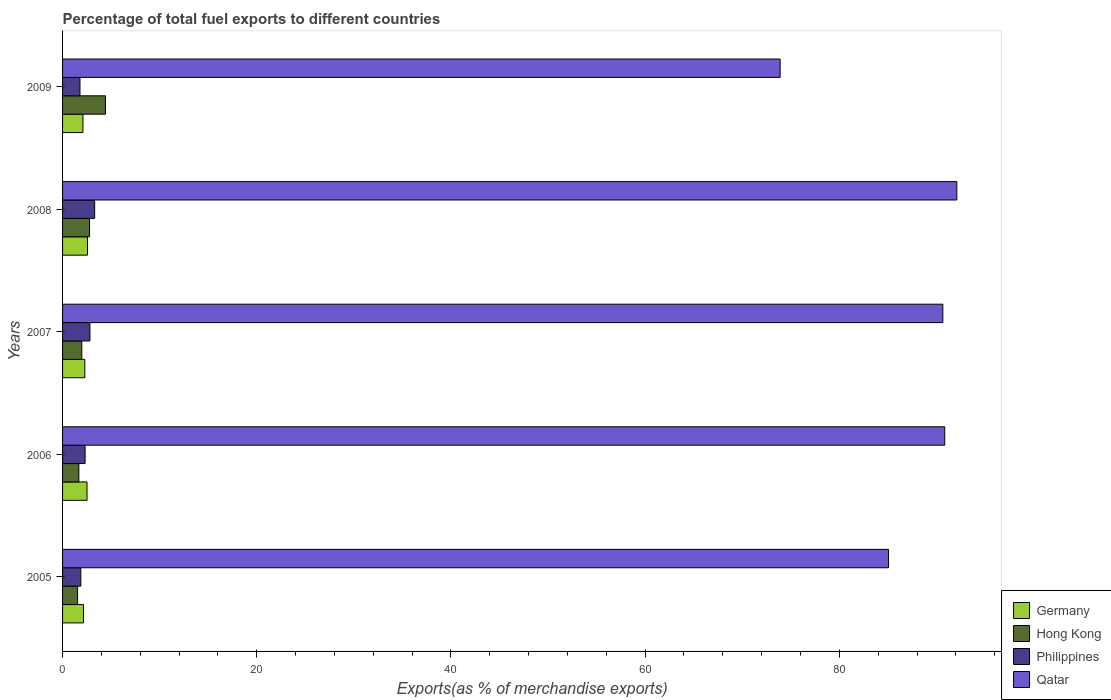How many groups of bars are there?
Give a very brief answer. 5. Are the number of bars per tick equal to the number of legend labels?
Offer a terse response. Yes. Are the number of bars on each tick of the Y-axis equal?
Your response must be concise. Yes. How many bars are there on the 1st tick from the bottom?
Offer a terse response. 4. What is the percentage of exports to different countries in Hong Kong in 2005?
Provide a succinct answer. 1.54. Across all years, what is the maximum percentage of exports to different countries in Germany?
Give a very brief answer. 2.57. Across all years, what is the minimum percentage of exports to different countries in Qatar?
Provide a short and direct response. 73.9. In which year was the percentage of exports to different countries in Qatar maximum?
Keep it short and to the point. 2008. In which year was the percentage of exports to different countries in Philippines minimum?
Ensure brevity in your answer.  2009. What is the total percentage of exports to different countries in Philippines in the graph?
Your answer should be compact. 12.12. What is the difference between the percentage of exports to different countries in Qatar in 2007 and that in 2009?
Provide a succinct answer. 16.76. What is the difference between the percentage of exports to different countries in Germany in 2005 and the percentage of exports to different countries in Qatar in 2007?
Give a very brief answer. -88.5. What is the average percentage of exports to different countries in Germany per year?
Offer a very short reply. 2.33. In the year 2005, what is the difference between the percentage of exports to different countries in Qatar and percentage of exports to different countries in Hong Kong?
Ensure brevity in your answer.  83.52. In how many years, is the percentage of exports to different countries in Qatar greater than 76 %?
Your answer should be compact. 4. What is the ratio of the percentage of exports to different countries in Germany in 2007 to that in 2009?
Ensure brevity in your answer.  1.09. Is the percentage of exports to different countries in Hong Kong in 2005 less than that in 2007?
Provide a short and direct response. Yes. What is the difference between the highest and the second highest percentage of exports to different countries in Germany?
Keep it short and to the point. 0.05. What is the difference between the highest and the lowest percentage of exports to different countries in Qatar?
Your answer should be compact. 18.2. Is it the case that in every year, the sum of the percentage of exports to different countries in Hong Kong and percentage of exports to different countries in Germany is greater than the sum of percentage of exports to different countries in Qatar and percentage of exports to different countries in Philippines?
Make the answer very short. No. What does the 4th bar from the bottom in 2005 represents?
Offer a very short reply. Qatar. Is it the case that in every year, the sum of the percentage of exports to different countries in Qatar and percentage of exports to different countries in Germany is greater than the percentage of exports to different countries in Hong Kong?
Offer a very short reply. Yes. Does the graph contain grids?
Provide a short and direct response. No. How are the legend labels stacked?
Make the answer very short. Vertical. What is the title of the graph?
Your response must be concise. Percentage of total fuel exports to different countries. What is the label or title of the X-axis?
Give a very brief answer. Exports(as % of merchandise exports). What is the label or title of the Y-axis?
Offer a very short reply. Years. What is the Exports(as % of merchandise exports) in Germany in 2005?
Offer a very short reply. 2.16. What is the Exports(as % of merchandise exports) of Hong Kong in 2005?
Offer a very short reply. 1.54. What is the Exports(as % of merchandise exports) in Philippines in 2005?
Ensure brevity in your answer.  1.88. What is the Exports(as % of merchandise exports) of Qatar in 2005?
Provide a succinct answer. 85.06. What is the Exports(as % of merchandise exports) of Germany in 2006?
Give a very brief answer. 2.52. What is the Exports(as % of merchandise exports) of Hong Kong in 2006?
Your answer should be very brief. 1.68. What is the Exports(as % of merchandise exports) in Philippines in 2006?
Ensure brevity in your answer.  2.32. What is the Exports(as % of merchandise exports) of Qatar in 2006?
Provide a short and direct response. 90.85. What is the Exports(as % of merchandise exports) in Germany in 2007?
Provide a short and direct response. 2.29. What is the Exports(as % of merchandise exports) of Hong Kong in 2007?
Keep it short and to the point. 1.98. What is the Exports(as % of merchandise exports) of Philippines in 2007?
Offer a terse response. 2.82. What is the Exports(as % of merchandise exports) in Qatar in 2007?
Give a very brief answer. 90.66. What is the Exports(as % of merchandise exports) of Germany in 2008?
Your answer should be very brief. 2.57. What is the Exports(as % of merchandise exports) in Hong Kong in 2008?
Provide a succinct answer. 2.78. What is the Exports(as % of merchandise exports) of Philippines in 2008?
Give a very brief answer. 3.3. What is the Exports(as % of merchandise exports) in Qatar in 2008?
Your answer should be compact. 92.1. What is the Exports(as % of merchandise exports) in Germany in 2009?
Make the answer very short. 2.1. What is the Exports(as % of merchandise exports) of Hong Kong in 2009?
Your response must be concise. 4.42. What is the Exports(as % of merchandise exports) in Philippines in 2009?
Offer a terse response. 1.79. What is the Exports(as % of merchandise exports) in Qatar in 2009?
Make the answer very short. 73.9. Across all years, what is the maximum Exports(as % of merchandise exports) in Germany?
Your response must be concise. 2.57. Across all years, what is the maximum Exports(as % of merchandise exports) in Hong Kong?
Your answer should be very brief. 4.42. Across all years, what is the maximum Exports(as % of merchandise exports) in Philippines?
Offer a terse response. 3.3. Across all years, what is the maximum Exports(as % of merchandise exports) in Qatar?
Keep it short and to the point. 92.1. Across all years, what is the minimum Exports(as % of merchandise exports) of Germany?
Make the answer very short. 2.1. Across all years, what is the minimum Exports(as % of merchandise exports) of Hong Kong?
Make the answer very short. 1.54. Across all years, what is the minimum Exports(as % of merchandise exports) of Philippines?
Offer a very short reply. 1.79. Across all years, what is the minimum Exports(as % of merchandise exports) of Qatar?
Your answer should be compact. 73.9. What is the total Exports(as % of merchandise exports) of Germany in the graph?
Make the answer very short. 11.64. What is the total Exports(as % of merchandise exports) in Hong Kong in the graph?
Keep it short and to the point. 12.4. What is the total Exports(as % of merchandise exports) of Philippines in the graph?
Offer a terse response. 12.12. What is the total Exports(as % of merchandise exports) in Qatar in the graph?
Provide a short and direct response. 432.57. What is the difference between the Exports(as % of merchandise exports) of Germany in 2005 and that in 2006?
Ensure brevity in your answer.  -0.36. What is the difference between the Exports(as % of merchandise exports) of Hong Kong in 2005 and that in 2006?
Your answer should be compact. -0.13. What is the difference between the Exports(as % of merchandise exports) in Philippines in 2005 and that in 2006?
Your answer should be compact. -0.44. What is the difference between the Exports(as % of merchandise exports) in Qatar in 2005 and that in 2006?
Offer a very short reply. -5.79. What is the difference between the Exports(as % of merchandise exports) of Germany in 2005 and that in 2007?
Provide a short and direct response. -0.13. What is the difference between the Exports(as % of merchandise exports) of Hong Kong in 2005 and that in 2007?
Your answer should be very brief. -0.44. What is the difference between the Exports(as % of merchandise exports) in Philippines in 2005 and that in 2007?
Offer a very short reply. -0.94. What is the difference between the Exports(as % of merchandise exports) of Qatar in 2005 and that in 2007?
Ensure brevity in your answer.  -5.6. What is the difference between the Exports(as % of merchandise exports) in Germany in 2005 and that in 2008?
Your answer should be compact. -0.41. What is the difference between the Exports(as % of merchandise exports) in Hong Kong in 2005 and that in 2008?
Keep it short and to the point. -1.24. What is the difference between the Exports(as % of merchandise exports) of Philippines in 2005 and that in 2008?
Your answer should be very brief. -1.42. What is the difference between the Exports(as % of merchandise exports) of Qatar in 2005 and that in 2008?
Ensure brevity in your answer.  -7.04. What is the difference between the Exports(as % of merchandise exports) of Germany in 2005 and that in 2009?
Provide a succinct answer. 0.06. What is the difference between the Exports(as % of merchandise exports) of Hong Kong in 2005 and that in 2009?
Make the answer very short. -2.88. What is the difference between the Exports(as % of merchandise exports) in Philippines in 2005 and that in 2009?
Offer a very short reply. 0.09. What is the difference between the Exports(as % of merchandise exports) of Qatar in 2005 and that in 2009?
Offer a terse response. 11.16. What is the difference between the Exports(as % of merchandise exports) of Germany in 2006 and that in 2007?
Provide a short and direct response. 0.23. What is the difference between the Exports(as % of merchandise exports) of Hong Kong in 2006 and that in 2007?
Offer a very short reply. -0.3. What is the difference between the Exports(as % of merchandise exports) of Philippines in 2006 and that in 2007?
Offer a very short reply. -0.5. What is the difference between the Exports(as % of merchandise exports) in Qatar in 2006 and that in 2007?
Make the answer very short. 0.2. What is the difference between the Exports(as % of merchandise exports) in Germany in 2006 and that in 2008?
Keep it short and to the point. -0.05. What is the difference between the Exports(as % of merchandise exports) of Hong Kong in 2006 and that in 2008?
Provide a succinct answer. -1.1. What is the difference between the Exports(as % of merchandise exports) of Philippines in 2006 and that in 2008?
Your answer should be very brief. -0.98. What is the difference between the Exports(as % of merchandise exports) in Qatar in 2006 and that in 2008?
Your answer should be compact. -1.25. What is the difference between the Exports(as % of merchandise exports) in Germany in 2006 and that in 2009?
Make the answer very short. 0.42. What is the difference between the Exports(as % of merchandise exports) in Hong Kong in 2006 and that in 2009?
Your answer should be compact. -2.74. What is the difference between the Exports(as % of merchandise exports) in Philippines in 2006 and that in 2009?
Your response must be concise. 0.53. What is the difference between the Exports(as % of merchandise exports) of Qatar in 2006 and that in 2009?
Make the answer very short. 16.95. What is the difference between the Exports(as % of merchandise exports) of Germany in 2007 and that in 2008?
Give a very brief answer. -0.27. What is the difference between the Exports(as % of merchandise exports) of Hong Kong in 2007 and that in 2008?
Make the answer very short. -0.8. What is the difference between the Exports(as % of merchandise exports) in Philippines in 2007 and that in 2008?
Offer a very short reply. -0.49. What is the difference between the Exports(as % of merchandise exports) in Qatar in 2007 and that in 2008?
Your answer should be very brief. -1.44. What is the difference between the Exports(as % of merchandise exports) of Germany in 2007 and that in 2009?
Give a very brief answer. 0.2. What is the difference between the Exports(as % of merchandise exports) in Hong Kong in 2007 and that in 2009?
Offer a very short reply. -2.44. What is the difference between the Exports(as % of merchandise exports) of Philippines in 2007 and that in 2009?
Your response must be concise. 1.02. What is the difference between the Exports(as % of merchandise exports) in Qatar in 2007 and that in 2009?
Your answer should be very brief. 16.76. What is the difference between the Exports(as % of merchandise exports) of Germany in 2008 and that in 2009?
Your response must be concise. 0.47. What is the difference between the Exports(as % of merchandise exports) in Hong Kong in 2008 and that in 2009?
Offer a very short reply. -1.64. What is the difference between the Exports(as % of merchandise exports) of Philippines in 2008 and that in 2009?
Provide a short and direct response. 1.51. What is the difference between the Exports(as % of merchandise exports) of Qatar in 2008 and that in 2009?
Keep it short and to the point. 18.2. What is the difference between the Exports(as % of merchandise exports) in Germany in 2005 and the Exports(as % of merchandise exports) in Hong Kong in 2006?
Provide a short and direct response. 0.48. What is the difference between the Exports(as % of merchandise exports) of Germany in 2005 and the Exports(as % of merchandise exports) of Philippines in 2006?
Provide a succinct answer. -0.16. What is the difference between the Exports(as % of merchandise exports) of Germany in 2005 and the Exports(as % of merchandise exports) of Qatar in 2006?
Your answer should be very brief. -88.69. What is the difference between the Exports(as % of merchandise exports) of Hong Kong in 2005 and the Exports(as % of merchandise exports) of Philippines in 2006?
Keep it short and to the point. -0.78. What is the difference between the Exports(as % of merchandise exports) of Hong Kong in 2005 and the Exports(as % of merchandise exports) of Qatar in 2006?
Give a very brief answer. -89.31. What is the difference between the Exports(as % of merchandise exports) of Philippines in 2005 and the Exports(as % of merchandise exports) of Qatar in 2006?
Provide a succinct answer. -88.97. What is the difference between the Exports(as % of merchandise exports) of Germany in 2005 and the Exports(as % of merchandise exports) of Hong Kong in 2007?
Offer a very short reply. 0.18. What is the difference between the Exports(as % of merchandise exports) of Germany in 2005 and the Exports(as % of merchandise exports) of Philippines in 2007?
Ensure brevity in your answer.  -0.66. What is the difference between the Exports(as % of merchandise exports) in Germany in 2005 and the Exports(as % of merchandise exports) in Qatar in 2007?
Provide a succinct answer. -88.5. What is the difference between the Exports(as % of merchandise exports) of Hong Kong in 2005 and the Exports(as % of merchandise exports) of Philippines in 2007?
Provide a short and direct response. -1.27. What is the difference between the Exports(as % of merchandise exports) in Hong Kong in 2005 and the Exports(as % of merchandise exports) in Qatar in 2007?
Your response must be concise. -89.11. What is the difference between the Exports(as % of merchandise exports) of Philippines in 2005 and the Exports(as % of merchandise exports) of Qatar in 2007?
Your response must be concise. -88.78. What is the difference between the Exports(as % of merchandise exports) in Germany in 2005 and the Exports(as % of merchandise exports) in Hong Kong in 2008?
Offer a very short reply. -0.62. What is the difference between the Exports(as % of merchandise exports) of Germany in 2005 and the Exports(as % of merchandise exports) of Philippines in 2008?
Make the answer very short. -1.15. What is the difference between the Exports(as % of merchandise exports) in Germany in 2005 and the Exports(as % of merchandise exports) in Qatar in 2008?
Your answer should be very brief. -89.94. What is the difference between the Exports(as % of merchandise exports) in Hong Kong in 2005 and the Exports(as % of merchandise exports) in Philippines in 2008?
Offer a very short reply. -1.76. What is the difference between the Exports(as % of merchandise exports) of Hong Kong in 2005 and the Exports(as % of merchandise exports) of Qatar in 2008?
Make the answer very short. -90.55. What is the difference between the Exports(as % of merchandise exports) in Philippines in 2005 and the Exports(as % of merchandise exports) in Qatar in 2008?
Offer a very short reply. -90.22. What is the difference between the Exports(as % of merchandise exports) in Germany in 2005 and the Exports(as % of merchandise exports) in Hong Kong in 2009?
Your response must be concise. -2.26. What is the difference between the Exports(as % of merchandise exports) of Germany in 2005 and the Exports(as % of merchandise exports) of Philippines in 2009?
Provide a short and direct response. 0.37. What is the difference between the Exports(as % of merchandise exports) in Germany in 2005 and the Exports(as % of merchandise exports) in Qatar in 2009?
Keep it short and to the point. -71.74. What is the difference between the Exports(as % of merchandise exports) of Hong Kong in 2005 and the Exports(as % of merchandise exports) of Philippines in 2009?
Provide a short and direct response. -0.25. What is the difference between the Exports(as % of merchandise exports) of Hong Kong in 2005 and the Exports(as % of merchandise exports) of Qatar in 2009?
Your response must be concise. -72.36. What is the difference between the Exports(as % of merchandise exports) in Philippines in 2005 and the Exports(as % of merchandise exports) in Qatar in 2009?
Give a very brief answer. -72.02. What is the difference between the Exports(as % of merchandise exports) in Germany in 2006 and the Exports(as % of merchandise exports) in Hong Kong in 2007?
Offer a very short reply. 0.54. What is the difference between the Exports(as % of merchandise exports) in Germany in 2006 and the Exports(as % of merchandise exports) in Philippines in 2007?
Ensure brevity in your answer.  -0.3. What is the difference between the Exports(as % of merchandise exports) of Germany in 2006 and the Exports(as % of merchandise exports) of Qatar in 2007?
Provide a short and direct response. -88.14. What is the difference between the Exports(as % of merchandise exports) of Hong Kong in 2006 and the Exports(as % of merchandise exports) of Philippines in 2007?
Provide a short and direct response. -1.14. What is the difference between the Exports(as % of merchandise exports) of Hong Kong in 2006 and the Exports(as % of merchandise exports) of Qatar in 2007?
Keep it short and to the point. -88.98. What is the difference between the Exports(as % of merchandise exports) in Philippines in 2006 and the Exports(as % of merchandise exports) in Qatar in 2007?
Give a very brief answer. -88.34. What is the difference between the Exports(as % of merchandise exports) in Germany in 2006 and the Exports(as % of merchandise exports) in Hong Kong in 2008?
Provide a succinct answer. -0.26. What is the difference between the Exports(as % of merchandise exports) in Germany in 2006 and the Exports(as % of merchandise exports) in Philippines in 2008?
Offer a terse response. -0.79. What is the difference between the Exports(as % of merchandise exports) in Germany in 2006 and the Exports(as % of merchandise exports) in Qatar in 2008?
Your response must be concise. -89.58. What is the difference between the Exports(as % of merchandise exports) of Hong Kong in 2006 and the Exports(as % of merchandise exports) of Philippines in 2008?
Provide a succinct answer. -1.63. What is the difference between the Exports(as % of merchandise exports) of Hong Kong in 2006 and the Exports(as % of merchandise exports) of Qatar in 2008?
Give a very brief answer. -90.42. What is the difference between the Exports(as % of merchandise exports) in Philippines in 2006 and the Exports(as % of merchandise exports) in Qatar in 2008?
Make the answer very short. -89.78. What is the difference between the Exports(as % of merchandise exports) in Germany in 2006 and the Exports(as % of merchandise exports) in Hong Kong in 2009?
Your response must be concise. -1.9. What is the difference between the Exports(as % of merchandise exports) in Germany in 2006 and the Exports(as % of merchandise exports) in Philippines in 2009?
Ensure brevity in your answer.  0.73. What is the difference between the Exports(as % of merchandise exports) of Germany in 2006 and the Exports(as % of merchandise exports) of Qatar in 2009?
Make the answer very short. -71.38. What is the difference between the Exports(as % of merchandise exports) in Hong Kong in 2006 and the Exports(as % of merchandise exports) in Philippines in 2009?
Make the answer very short. -0.12. What is the difference between the Exports(as % of merchandise exports) of Hong Kong in 2006 and the Exports(as % of merchandise exports) of Qatar in 2009?
Give a very brief answer. -72.22. What is the difference between the Exports(as % of merchandise exports) in Philippines in 2006 and the Exports(as % of merchandise exports) in Qatar in 2009?
Provide a short and direct response. -71.58. What is the difference between the Exports(as % of merchandise exports) in Germany in 2007 and the Exports(as % of merchandise exports) in Hong Kong in 2008?
Keep it short and to the point. -0.49. What is the difference between the Exports(as % of merchandise exports) in Germany in 2007 and the Exports(as % of merchandise exports) in Philippines in 2008?
Provide a short and direct response. -1.01. What is the difference between the Exports(as % of merchandise exports) of Germany in 2007 and the Exports(as % of merchandise exports) of Qatar in 2008?
Ensure brevity in your answer.  -89.81. What is the difference between the Exports(as % of merchandise exports) of Hong Kong in 2007 and the Exports(as % of merchandise exports) of Philippines in 2008?
Your answer should be compact. -1.33. What is the difference between the Exports(as % of merchandise exports) of Hong Kong in 2007 and the Exports(as % of merchandise exports) of Qatar in 2008?
Offer a very short reply. -90.12. What is the difference between the Exports(as % of merchandise exports) of Philippines in 2007 and the Exports(as % of merchandise exports) of Qatar in 2008?
Your answer should be compact. -89.28. What is the difference between the Exports(as % of merchandise exports) in Germany in 2007 and the Exports(as % of merchandise exports) in Hong Kong in 2009?
Offer a terse response. -2.13. What is the difference between the Exports(as % of merchandise exports) of Germany in 2007 and the Exports(as % of merchandise exports) of Philippines in 2009?
Your answer should be compact. 0.5. What is the difference between the Exports(as % of merchandise exports) in Germany in 2007 and the Exports(as % of merchandise exports) in Qatar in 2009?
Provide a succinct answer. -71.61. What is the difference between the Exports(as % of merchandise exports) of Hong Kong in 2007 and the Exports(as % of merchandise exports) of Philippines in 2009?
Provide a succinct answer. 0.19. What is the difference between the Exports(as % of merchandise exports) in Hong Kong in 2007 and the Exports(as % of merchandise exports) in Qatar in 2009?
Provide a succinct answer. -71.92. What is the difference between the Exports(as % of merchandise exports) of Philippines in 2007 and the Exports(as % of merchandise exports) of Qatar in 2009?
Your answer should be compact. -71.08. What is the difference between the Exports(as % of merchandise exports) of Germany in 2008 and the Exports(as % of merchandise exports) of Hong Kong in 2009?
Keep it short and to the point. -1.85. What is the difference between the Exports(as % of merchandise exports) in Germany in 2008 and the Exports(as % of merchandise exports) in Philippines in 2009?
Offer a very short reply. 0.77. What is the difference between the Exports(as % of merchandise exports) of Germany in 2008 and the Exports(as % of merchandise exports) of Qatar in 2009?
Provide a succinct answer. -71.33. What is the difference between the Exports(as % of merchandise exports) in Hong Kong in 2008 and the Exports(as % of merchandise exports) in Philippines in 2009?
Offer a very short reply. 0.99. What is the difference between the Exports(as % of merchandise exports) of Hong Kong in 2008 and the Exports(as % of merchandise exports) of Qatar in 2009?
Provide a short and direct response. -71.12. What is the difference between the Exports(as % of merchandise exports) of Philippines in 2008 and the Exports(as % of merchandise exports) of Qatar in 2009?
Ensure brevity in your answer.  -70.6. What is the average Exports(as % of merchandise exports) in Germany per year?
Your answer should be compact. 2.33. What is the average Exports(as % of merchandise exports) of Hong Kong per year?
Give a very brief answer. 2.48. What is the average Exports(as % of merchandise exports) of Philippines per year?
Provide a succinct answer. 2.42. What is the average Exports(as % of merchandise exports) of Qatar per year?
Keep it short and to the point. 86.51. In the year 2005, what is the difference between the Exports(as % of merchandise exports) of Germany and Exports(as % of merchandise exports) of Hong Kong?
Make the answer very short. 0.61. In the year 2005, what is the difference between the Exports(as % of merchandise exports) in Germany and Exports(as % of merchandise exports) in Philippines?
Your answer should be very brief. 0.28. In the year 2005, what is the difference between the Exports(as % of merchandise exports) of Germany and Exports(as % of merchandise exports) of Qatar?
Offer a terse response. -82.9. In the year 2005, what is the difference between the Exports(as % of merchandise exports) of Hong Kong and Exports(as % of merchandise exports) of Philippines?
Keep it short and to the point. -0.34. In the year 2005, what is the difference between the Exports(as % of merchandise exports) of Hong Kong and Exports(as % of merchandise exports) of Qatar?
Give a very brief answer. -83.52. In the year 2005, what is the difference between the Exports(as % of merchandise exports) in Philippines and Exports(as % of merchandise exports) in Qatar?
Offer a terse response. -83.18. In the year 2006, what is the difference between the Exports(as % of merchandise exports) in Germany and Exports(as % of merchandise exports) in Hong Kong?
Give a very brief answer. 0.84. In the year 2006, what is the difference between the Exports(as % of merchandise exports) of Germany and Exports(as % of merchandise exports) of Philippines?
Offer a terse response. 0.2. In the year 2006, what is the difference between the Exports(as % of merchandise exports) of Germany and Exports(as % of merchandise exports) of Qatar?
Give a very brief answer. -88.33. In the year 2006, what is the difference between the Exports(as % of merchandise exports) in Hong Kong and Exports(as % of merchandise exports) in Philippines?
Your answer should be very brief. -0.64. In the year 2006, what is the difference between the Exports(as % of merchandise exports) of Hong Kong and Exports(as % of merchandise exports) of Qatar?
Offer a terse response. -89.18. In the year 2006, what is the difference between the Exports(as % of merchandise exports) in Philippines and Exports(as % of merchandise exports) in Qatar?
Offer a very short reply. -88.53. In the year 2007, what is the difference between the Exports(as % of merchandise exports) in Germany and Exports(as % of merchandise exports) in Hong Kong?
Make the answer very short. 0.31. In the year 2007, what is the difference between the Exports(as % of merchandise exports) of Germany and Exports(as % of merchandise exports) of Philippines?
Give a very brief answer. -0.52. In the year 2007, what is the difference between the Exports(as % of merchandise exports) of Germany and Exports(as % of merchandise exports) of Qatar?
Give a very brief answer. -88.36. In the year 2007, what is the difference between the Exports(as % of merchandise exports) in Hong Kong and Exports(as % of merchandise exports) in Philippines?
Keep it short and to the point. -0.84. In the year 2007, what is the difference between the Exports(as % of merchandise exports) of Hong Kong and Exports(as % of merchandise exports) of Qatar?
Your answer should be compact. -88.68. In the year 2007, what is the difference between the Exports(as % of merchandise exports) of Philippines and Exports(as % of merchandise exports) of Qatar?
Your answer should be very brief. -87.84. In the year 2008, what is the difference between the Exports(as % of merchandise exports) of Germany and Exports(as % of merchandise exports) of Hong Kong?
Your response must be concise. -0.21. In the year 2008, what is the difference between the Exports(as % of merchandise exports) of Germany and Exports(as % of merchandise exports) of Philippines?
Offer a very short reply. -0.74. In the year 2008, what is the difference between the Exports(as % of merchandise exports) of Germany and Exports(as % of merchandise exports) of Qatar?
Make the answer very short. -89.53. In the year 2008, what is the difference between the Exports(as % of merchandise exports) in Hong Kong and Exports(as % of merchandise exports) in Philippines?
Your answer should be very brief. -0.52. In the year 2008, what is the difference between the Exports(as % of merchandise exports) of Hong Kong and Exports(as % of merchandise exports) of Qatar?
Your answer should be compact. -89.32. In the year 2008, what is the difference between the Exports(as % of merchandise exports) of Philippines and Exports(as % of merchandise exports) of Qatar?
Your answer should be very brief. -88.79. In the year 2009, what is the difference between the Exports(as % of merchandise exports) in Germany and Exports(as % of merchandise exports) in Hong Kong?
Offer a very short reply. -2.32. In the year 2009, what is the difference between the Exports(as % of merchandise exports) of Germany and Exports(as % of merchandise exports) of Philippines?
Offer a very short reply. 0.3. In the year 2009, what is the difference between the Exports(as % of merchandise exports) of Germany and Exports(as % of merchandise exports) of Qatar?
Offer a very short reply. -71.8. In the year 2009, what is the difference between the Exports(as % of merchandise exports) of Hong Kong and Exports(as % of merchandise exports) of Philippines?
Make the answer very short. 2.63. In the year 2009, what is the difference between the Exports(as % of merchandise exports) of Hong Kong and Exports(as % of merchandise exports) of Qatar?
Ensure brevity in your answer.  -69.48. In the year 2009, what is the difference between the Exports(as % of merchandise exports) in Philippines and Exports(as % of merchandise exports) in Qatar?
Your answer should be compact. -72.11. What is the ratio of the Exports(as % of merchandise exports) of Germany in 2005 to that in 2006?
Your answer should be compact. 0.86. What is the ratio of the Exports(as % of merchandise exports) in Hong Kong in 2005 to that in 2006?
Make the answer very short. 0.92. What is the ratio of the Exports(as % of merchandise exports) in Philippines in 2005 to that in 2006?
Offer a very short reply. 0.81. What is the ratio of the Exports(as % of merchandise exports) in Qatar in 2005 to that in 2006?
Your response must be concise. 0.94. What is the ratio of the Exports(as % of merchandise exports) in Germany in 2005 to that in 2007?
Offer a terse response. 0.94. What is the ratio of the Exports(as % of merchandise exports) of Hong Kong in 2005 to that in 2007?
Provide a succinct answer. 0.78. What is the ratio of the Exports(as % of merchandise exports) in Philippines in 2005 to that in 2007?
Offer a terse response. 0.67. What is the ratio of the Exports(as % of merchandise exports) of Qatar in 2005 to that in 2007?
Provide a succinct answer. 0.94. What is the ratio of the Exports(as % of merchandise exports) in Germany in 2005 to that in 2008?
Give a very brief answer. 0.84. What is the ratio of the Exports(as % of merchandise exports) of Hong Kong in 2005 to that in 2008?
Ensure brevity in your answer.  0.56. What is the ratio of the Exports(as % of merchandise exports) in Philippines in 2005 to that in 2008?
Offer a terse response. 0.57. What is the ratio of the Exports(as % of merchandise exports) in Qatar in 2005 to that in 2008?
Ensure brevity in your answer.  0.92. What is the ratio of the Exports(as % of merchandise exports) in Germany in 2005 to that in 2009?
Your answer should be compact. 1.03. What is the ratio of the Exports(as % of merchandise exports) in Hong Kong in 2005 to that in 2009?
Offer a very short reply. 0.35. What is the ratio of the Exports(as % of merchandise exports) in Philippines in 2005 to that in 2009?
Keep it short and to the point. 1.05. What is the ratio of the Exports(as % of merchandise exports) of Qatar in 2005 to that in 2009?
Keep it short and to the point. 1.15. What is the ratio of the Exports(as % of merchandise exports) of Germany in 2006 to that in 2007?
Ensure brevity in your answer.  1.1. What is the ratio of the Exports(as % of merchandise exports) of Hong Kong in 2006 to that in 2007?
Give a very brief answer. 0.85. What is the ratio of the Exports(as % of merchandise exports) of Philippines in 2006 to that in 2007?
Your response must be concise. 0.82. What is the ratio of the Exports(as % of merchandise exports) in Qatar in 2006 to that in 2007?
Provide a succinct answer. 1. What is the ratio of the Exports(as % of merchandise exports) of Germany in 2006 to that in 2008?
Ensure brevity in your answer.  0.98. What is the ratio of the Exports(as % of merchandise exports) in Hong Kong in 2006 to that in 2008?
Offer a terse response. 0.6. What is the ratio of the Exports(as % of merchandise exports) of Philippines in 2006 to that in 2008?
Your answer should be compact. 0.7. What is the ratio of the Exports(as % of merchandise exports) in Qatar in 2006 to that in 2008?
Your answer should be compact. 0.99. What is the ratio of the Exports(as % of merchandise exports) of Germany in 2006 to that in 2009?
Your answer should be compact. 1.2. What is the ratio of the Exports(as % of merchandise exports) in Hong Kong in 2006 to that in 2009?
Your answer should be compact. 0.38. What is the ratio of the Exports(as % of merchandise exports) of Philippines in 2006 to that in 2009?
Offer a very short reply. 1.29. What is the ratio of the Exports(as % of merchandise exports) in Qatar in 2006 to that in 2009?
Your answer should be very brief. 1.23. What is the ratio of the Exports(as % of merchandise exports) of Germany in 2007 to that in 2008?
Your answer should be compact. 0.89. What is the ratio of the Exports(as % of merchandise exports) of Hong Kong in 2007 to that in 2008?
Your answer should be very brief. 0.71. What is the ratio of the Exports(as % of merchandise exports) in Philippines in 2007 to that in 2008?
Give a very brief answer. 0.85. What is the ratio of the Exports(as % of merchandise exports) of Qatar in 2007 to that in 2008?
Keep it short and to the point. 0.98. What is the ratio of the Exports(as % of merchandise exports) of Germany in 2007 to that in 2009?
Ensure brevity in your answer.  1.09. What is the ratio of the Exports(as % of merchandise exports) of Hong Kong in 2007 to that in 2009?
Give a very brief answer. 0.45. What is the ratio of the Exports(as % of merchandise exports) in Philippines in 2007 to that in 2009?
Your answer should be very brief. 1.57. What is the ratio of the Exports(as % of merchandise exports) of Qatar in 2007 to that in 2009?
Your response must be concise. 1.23. What is the ratio of the Exports(as % of merchandise exports) of Germany in 2008 to that in 2009?
Provide a short and direct response. 1.22. What is the ratio of the Exports(as % of merchandise exports) of Hong Kong in 2008 to that in 2009?
Your response must be concise. 0.63. What is the ratio of the Exports(as % of merchandise exports) of Philippines in 2008 to that in 2009?
Keep it short and to the point. 1.84. What is the ratio of the Exports(as % of merchandise exports) of Qatar in 2008 to that in 2009?
Provide a succinct answer. 1.25. What is the difference between the highest and the second highest Exports(as % of merchandise exports) in Germany?
Your response must be concise. 0.05. What is the difference between the highest and the second highest Exports(as % of merchandise exports) in Hong Kong?
Offer a terse response. 1.64. What is the difference between the highest and the second highest Exports(as % of merchandise exports) in Philippines?
Your answer should be very brief. 0.49. What is the difference between the highest and the second highest Exports(as % of merchandise exports) of Qatar?
Offer a very short reply. 1.25. What is the difference between the highest and the lowest Exports(as % of merchandise exports) of Germany?
Keep it short and to the point. 0.47. What is the difference between the highest and the lowest Exports(as % of merchandise exports) in Hong Kong?
Provide a succinct answer. 2.88. What is the difference between the highest and the lowest Exports(as % of merchandise exports) in Philippines?
Provide a succinct answer. 1.51. What is the difference between the highest and the lowest Exports(as % of merchandise exports) of Qatar?
Offer a very short reply. 18.2. 